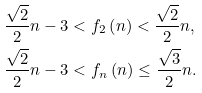Convert formula to latex. <formula><loc_0><loc_0><loc_500><loc_500>\frac { \sqrt { 2 } } { 2 } n - 3 & < f _ { 2 } \left ( n \right ) < \frac { \sqrt { 2 } } { 2 } n , \\ \frac { \sqrt { 2 } } { 2 } n - 3 & < f _ { n } \left ( n \right ) \leq \frac { \sqrt { 3 } } { 2 } n .</formula> 